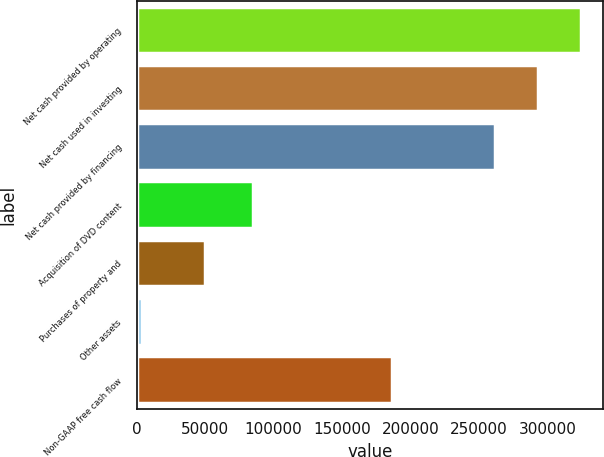Convert chart to OTSL. <chart><loc_0><loc_0><loc_500><loc_500><bar_chart><fcel>Net cash provided by operating<fcel>Net cash used in investing<fcel>Net cash provided by financing<fcel>Acquisition of DVD content<fcel>Purchases of property and<fcel>Other assets<fcel>Non-GAAP free cash flow<nl><fcel>324464<fcel>293060<fcel>261656<fcel>85154<fcel>49682<fcel>3674<fcel>186550<nl></chart> 